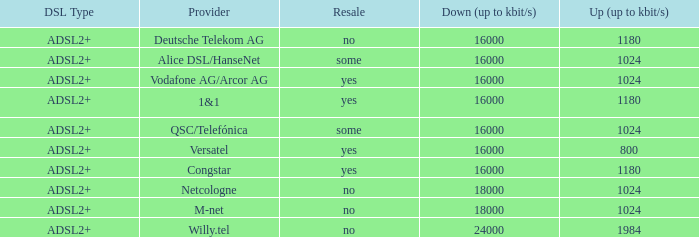Would you mind parsing the complete table? {'header': ['DSL Type', 'Provider', 'Resale', 'Down (up to kbit/s)', 'Up (up to kbit/s)'], 'rows': [['ADSL2+', 'Deutsche Telekom AG', 'no', '16000', '1180'], ['ADSL2+', 'Alice DSL/HanseNet', 'some', '16000', '1024'], ['ADSL2+', 'Vodafone AG/Arcor AG', 'yes', '16000', '1024'], ['ADSL2+', '1&1', 'yes', '16000', '1180'], ['ADSL2+', 'QSC/Telefónica', 'some', '16000', '1024'], ['ADSL2+', 'Versatel', 'yes', '16000', '800'], ['ADSL2+', 'Congstar', 'yes', '16000', '1180'], ['ADSL2+', 'Netcologne', 'no', '18000', '1024'], ['ADSL2+', 'M-net', 'no', '18000', '1024'], ['ADSL2+', 'Willy.tel', 'no', '24000', '1984']]} Who are all of the telecom providers for which the upload rate is 1024 kbits and the resale category is yes? Vodafone AG/Arcor AG. 